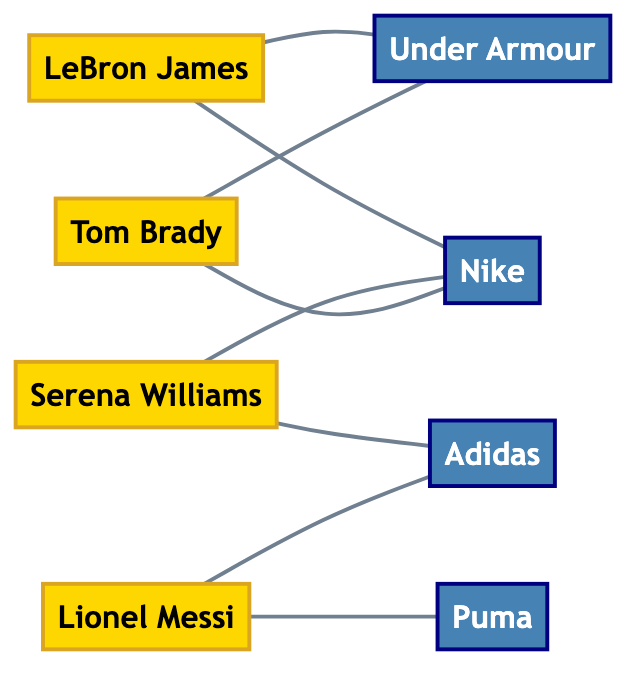What athlete prefers Nike? By checking the edges connected to the Nike node, we find LeBron James, Serena Williams, and Tom Brady are all linked with a "prefers" relationship to Nike.
Answer: LeBron James, Serena Williams, Tom Brady How many athletes are represented in the graph? The nodes labeled as athletes are LeBron James, Serena Williams, Lionel Messi, and Tom Brady, totaling four unique athlete nodes.
Answer: 4 Which brand do both Lionel Messi and Serena Williams prefer? From the graph, we see that Lionel Messi prefers Adidas and Puma, while Serena Williams prefers Nike and Adidas. The common brand between them is Adidas.
Answer: Adidas How many total edges are in the diagram? By counting the connections (edges) between all nodes, we identify a total of eight relationships (prefers) in the graph.
Answer: 8 Which brand do Tom Brady and LeBron James both prefer? Reviewing the edges for both athletes, we see that they both prefer Nike, as both are directly connected to the Nike node.
Answer: Nike How many brands are mentioned in the graph? By analyzing the nodes, we count a total of four distinct brand nodes: Nike, Adidas, Under Armour, and Puma.
Answer: 4 Which athlete prefers the most brands? Looking at the connections, both LeBron James and Tom Brady are linked to two brands each, while Serena Williams and Lionel Messi are linked to two brands as well; therefore, all four athletes prefer the same number of brands overall.
Answer: All prefer two brands What is the type of the node for Tom Brady? Checking the node representing Tom Brady, we find that he is classified as an athlete.
Answer: Athlete 